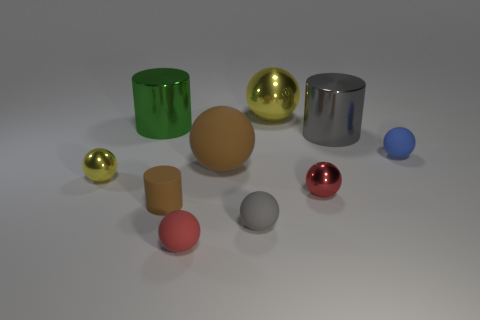What number of objects are either large yellow balls or small red things in front of the tiny gray rubber sphere?
Your answer should be very brief. 2. Are there more large yellow shiny balls than purple cylinders?
Offer a terse response. Yes. What shape is the thing behind the big green shiny thing?
Ensure brevity in your answer.  Sphere. What number of small gray things have the same shape as the big yellow object?
Your answer should be very brief. 1. There is a yellow sphere to the right of the metal sphere left of the large yellow thing; what is its size?
Offer a very short reply. Large. What number of blue things are matte things or small things?
Your response must be concise. 1. Is the number of tiny red balls to the right of the tiny blue thing less than the number of tiny yellow spheres that are on the right side of the gray metal cylinder?
Provide a short and direct response. No. There is a blue ball; is its size the same as the yellow ball in front of the brown rubber sphere?
Provide a short and direct response. Yes. What number of other red matte things have the same size as the red matte object?
Give a very brief answer. 0. What number of small things are either brown cylinders or yellow metallic objects?
Your answer should be very brief. 2. 